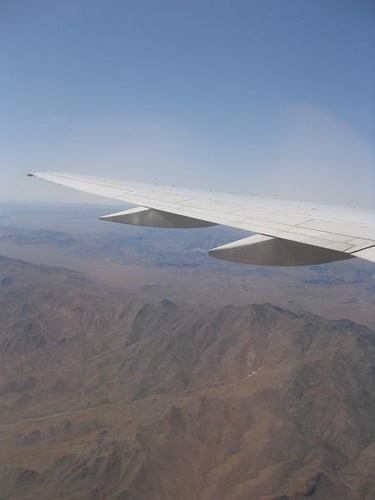Describe the objects in this image and their specific colors. I can see a airplane in gray, lightgray, and darkgray tones in this image. 